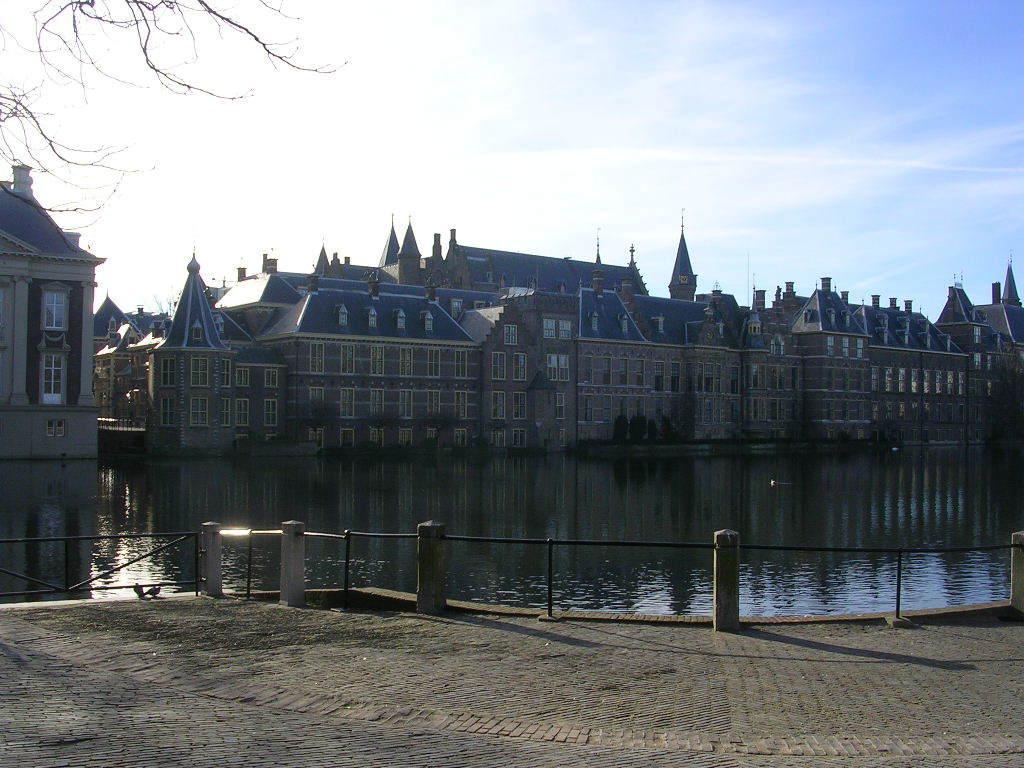Please provide a concise description of this image. In this picture I can see many buildings. In the center I can see the lake, beside that I can see some plants. At the bottom I can see the fencing. In the bottom left corner there are two birds near to the fencing. At the top I can see the sky and clouds. In the top left corner I can see the tree branches. 